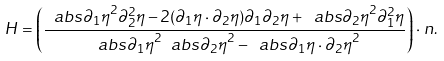Convert formula to latex. <formula><loc_0><loc_0><loc_500><loc_500>H = \left ( \frac { \ a b s { \partial _ { 1 } \eta } ^ { 2 } \partial _ { 2 } ^ { 2 } \eta - 2 ( \partial _ { 1 } \eta \cdot \partial _ { 2 } \eta ) \partial _ { 1 } \partial _ { 2 } \eta + \ a b s { \partial _ { 2 } \eta } ^ { 2 } \partial _ { 1 } ^ { 2 } \eta } { \ a b s { \partial _ { 1 } \eta } ^ { 2 } \ a b s { \partial _ { 2 } \eta } ^ { 2 } - \ a b s { \partial _ { 1 } \eta \cdot \partial _ { 2 } \eta } ^ { 2 } } \right ) \cdot n .</formula> 